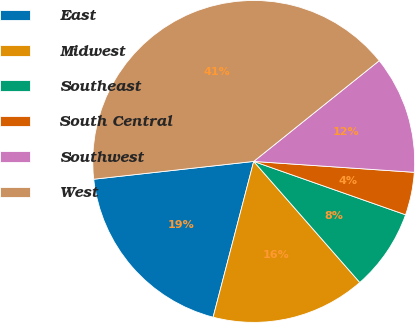Convert chart. <chart><loc_0><loc_0><loc_500><loc_500><pie_chart><fcel>East<fcel>Midwest<fcel>Southeast<fcel>South Central<fcel>Southwest<fcel>West<nl><fcel>19.18%<fcel>15.51%<fcel>8.17%<fcel>4.3%<fcel>11.84%<fcel>41.0%<nl></chart> 